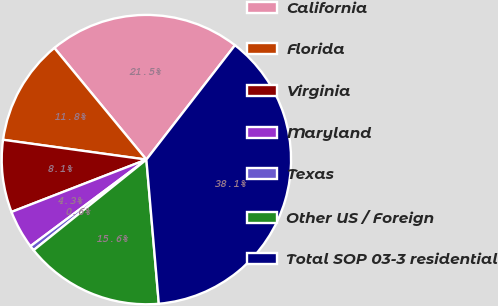<chart> <loc_0><loc_0><loc_500><loc_500><pie_chart><fcel>California<fcel>Florida<fcel>Virginia<fcel>Maryland<fcel>Texas<fcel>Other US / Foreign<fcel>Total SOP 03-3 residential<nl><fcel>21.46%<fcel>11.84%<fcel>8.08%<fcel>4.32%<fcel>0.56%<fcel>15.6%<fcel>38.14%<nl></chart> 